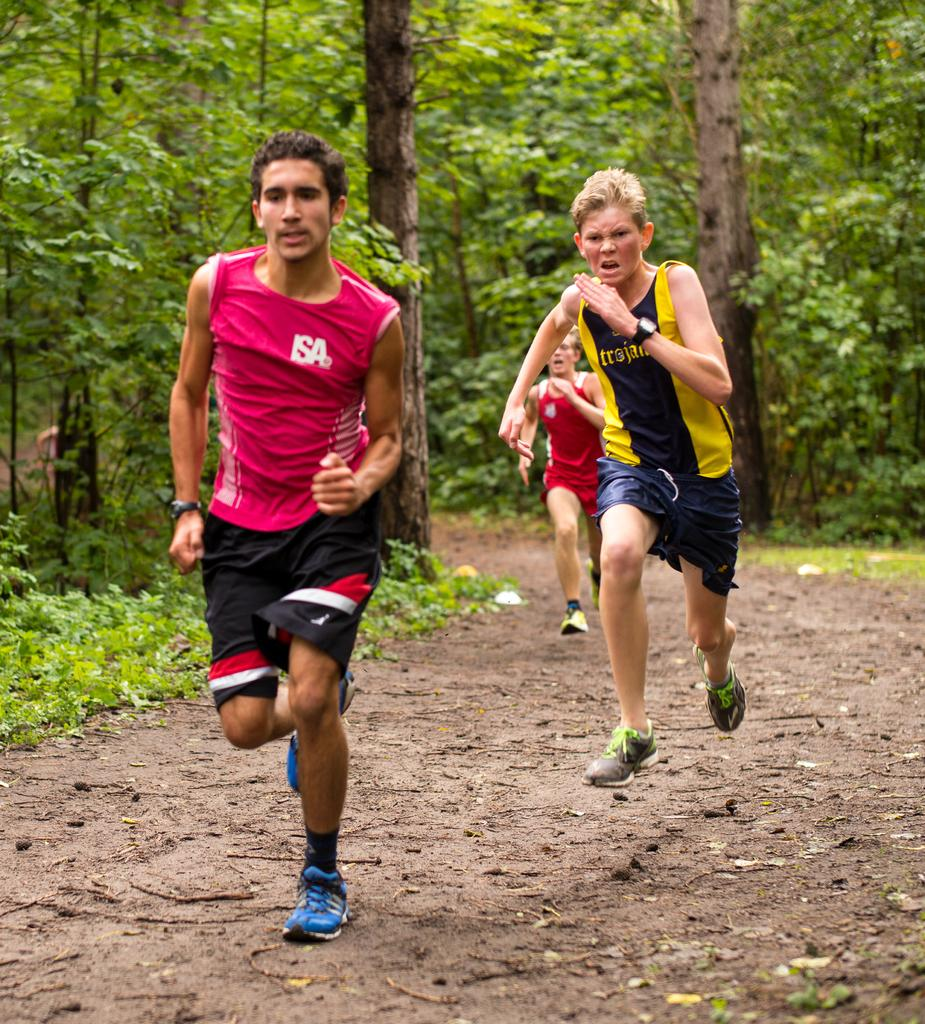How many people are in the image? There are three people in the image. What are the people doing in the image? The people are running in the image. What type of surface are they running on? They are running on a mud road. What mass of the act of copying can be seen in the image? There is no act of copying or mass present in the image; it features three people running on a mud road. 